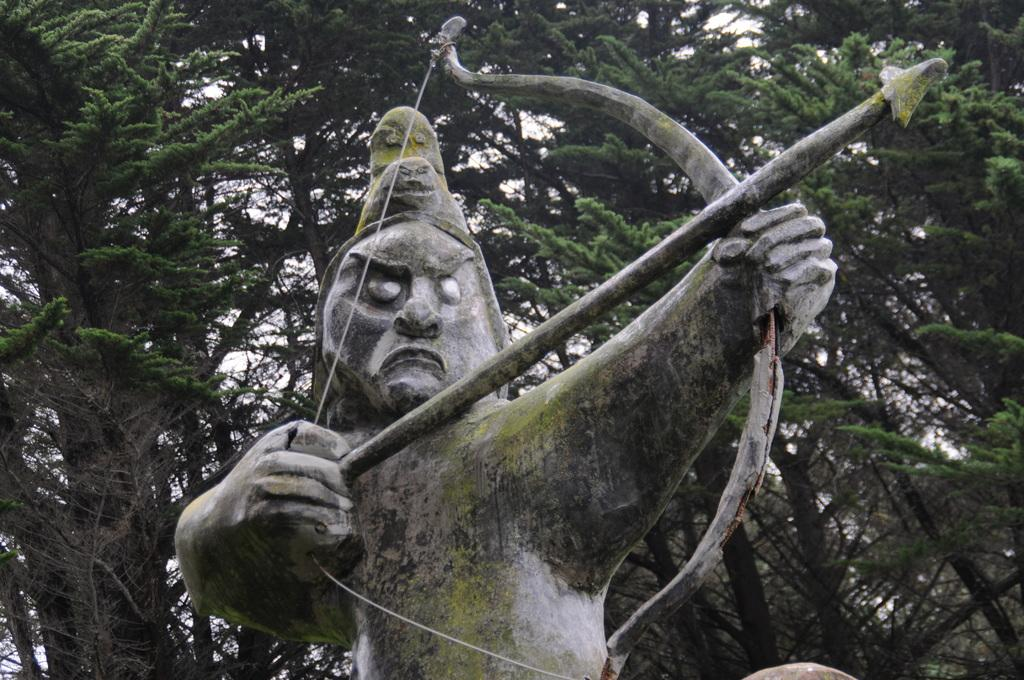What is the main subject of the image? There is a sculpture in the image. What is the sculpture holding in its hands? The sculpture is holding a bow and an arrow. What can be seen in the background of the image? There are trees and the sky visible in the background of the image. What type of glue is being used to attach the berry to the sculpture in the image? There is no berry present in the image, and therefore no glue or attachment process can be observed. 